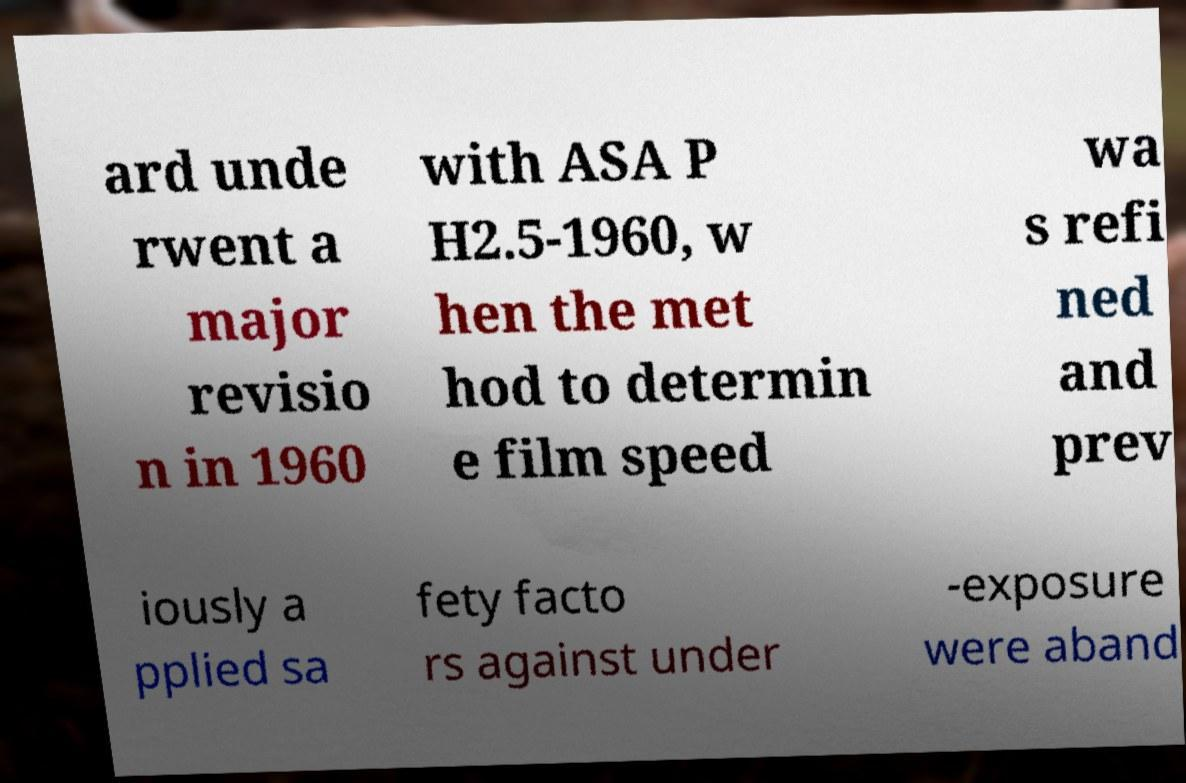What messages or text are displayed in this image? I need them in a readable, typed format. ard unde rwent a major revisio n in 1960 with ASA P H2.5-1960, w hen the met hod to determin e film speed wa s refi ned and prev iously a pplied sa fety facto rs against under -exposure were aband 